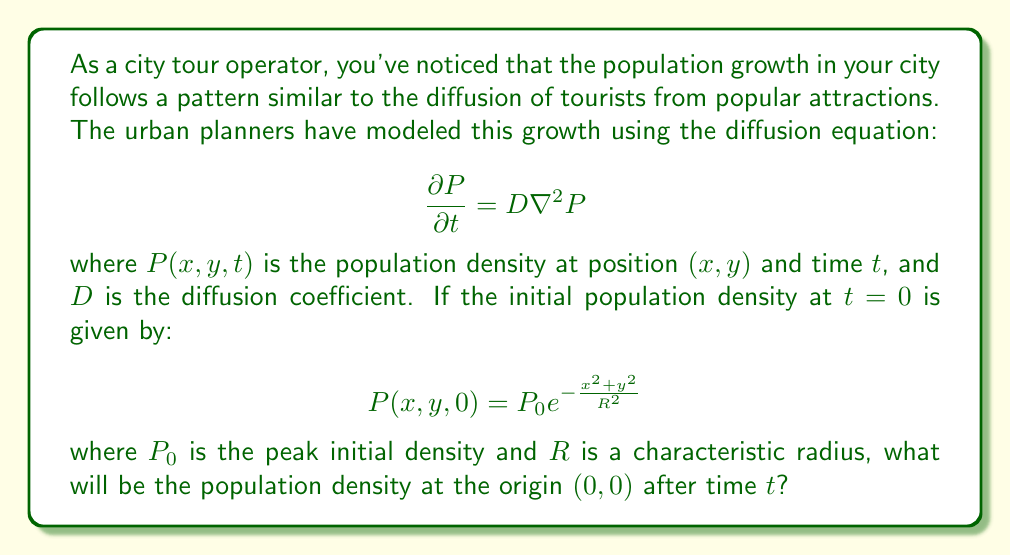What is the answer to this math problem? To solve this problem, we need to use the solution to the 2D diffusion equation with an initial Gaussian distribution. The steps are as follows:

1) The general solution for the 2D diffusion equation with an initial Gaussian distribution is:

   $$P(x,y,t) = \frac{P_0 R^2}{R^2 + 4Dt} \exp\left(-\frac{x^2+y^2}{R^2 + 4Dt}\right)$$

2) We're interested in the population density at the origin $(0,0)$ after time $t$. So, we need to evaluate $P(0,0,t)$:

   $$P(0,0,t) = \frac{P_0 R^2}{R^2 + 4Dt} \exp\left(-\frac{0^2+0^2}{R^2 + 4Dt}\right)$$

3) Simplify:

   $$P(0,0,t) = \frac{P_0 R^2}{R^2 + 4Dt} \exp(0) = \frac{P_0 R^2}{R^2 + 4Dt}$$

This expression gives us the population density at the origin $(0,0)$ after time $t$.
Answer: $$P(0,0,t) = \frac{P_0 R^2}{R^2 + 4Dt}$$ 